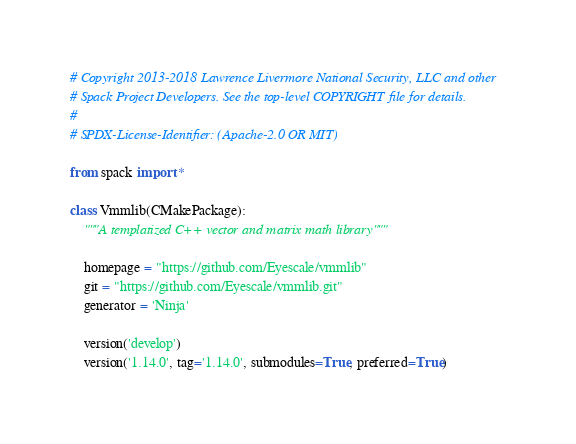Convert code to text. <code><loc_0><loc_0><loc_500><loc_500><_Python_># Copyright 2013-2018 Lawrence Livermore National Security, LLC and other
# Spack Project Developers. See the top-level COPYRIGHT file for details.
#
# SPDX-License-Identifier: (Apache-2.0 OR MIT)

from spack import *

class Vmmlib(CMakePackage):
    """A templatized C++ vector and matrix math library"""

    homepage = "https://github.com/Eyescale/vmmlib"
    git = "https://github.com/Eyescale/vmmlib.git"
    generator = 'Ninja'

    version('develop')
    version('1.14.0', tag='1.14.0', submodules=True, preferred=True)
</code> 